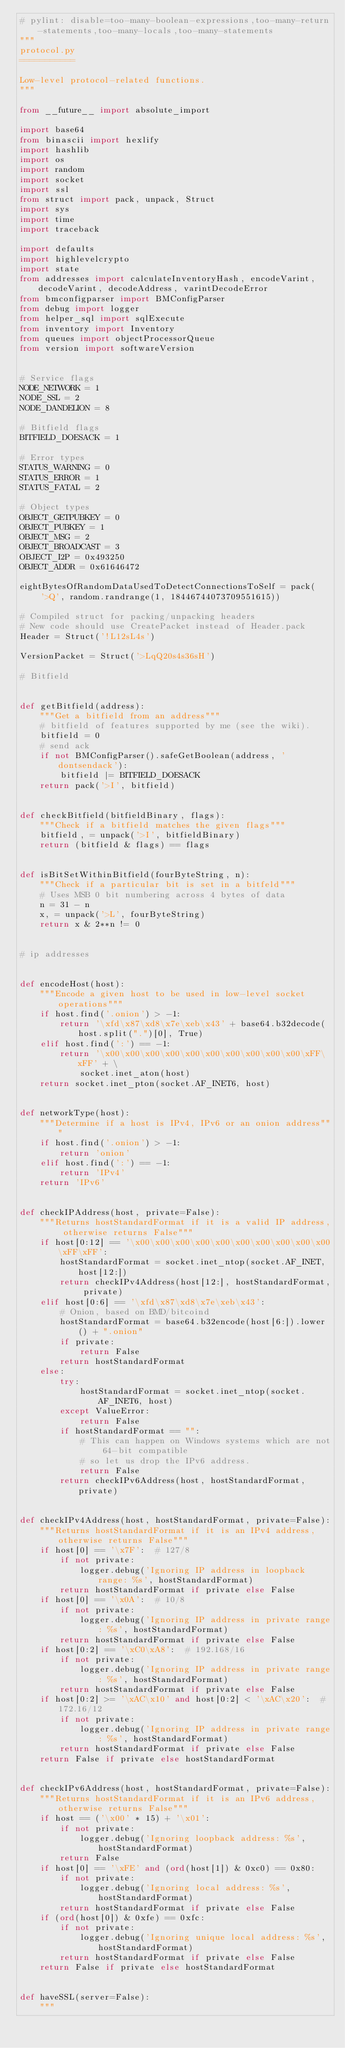Convert code to text. <code><loc_0><loc_0><loc_500><loc_500><_Python_># pylint: disable=too-many-boolean-expressions,too-many-return-statements,too-many-locals,too-many-statements
"""
protocol.py
===========

Low-level protocol-related functions.
"""

from __future__ import absolute_import

import base64
from binascii import hexlify
import hashlib
import os
import random
import socket
import ssl
from struct import pack, unpack, Struct
import sys
import time
import traceback

import defaults
import highlevelcrypto
import state
from addresses import calculateInventoryHash, encodeVarint, decodeVarint, decodeAddress, varintDecodeError
from bmconfigparser import BMConfigParser
from debug import logger
from helper_sql import sqlExecute
from inventory import Inventory
from queues import objectProcessorQueue
from version import softwareVersion


# Service flags
NODE_NETWORK = 1
NODE_SSL = 2
NODE_DANDELION = 8

# Bitfield flags
BITFIELD_DOESACK = 1

# Error types
STATUS_WARNING = 0
STATUS_ERROR = 1
STATUS_FATAL = 2

# Object types
OBJECT_GETPUBKEY = 0
OBJECT_PUBKEY = 1
OBJECT_MSG = 2
OBJECT_BROADCAST = 3
OBJECT_I2P = 0x493250
OBJECT_ADDR = 0x61646472

eightBytesOfRandomDataUsedToDetectConnectionsToSelf = pack(
    '>Q', random.randrange(1, 18446744073709551615))

# Compiled struct for packing/unpacking headers
# New code should use CreatePacket instead of Header.pack
Header = Struct('!L12sL4s')

VersionPacket = Struct('>LqQ20s4s36sH')

# Bitfield


def getBitfield(address):
    """Get a bitfield from an address"""
    # bitfield of features supported by me (see the wiki).
    bitfield = 0
    # send ack
    if not BMConfigParser().safeGetBoolean(address, 'dontsendack'):
        bitfield |= BITFIELD_DOESACK
    return pack('>I', bitfield)


def checkBitfield(bitfieldBinary, flags):
    """Check if a bitfield matches the given flags"""
    bitfield, = unpack('>I', bitfieldBinary)
    return (bitfield & flags) == flags


def isBitSetWithinBitfield(fourByteString, n):
    """Check if a particular bit is set in a bitfeld"""
    # Uses MSB 0 bit numbering across 4 bytes of data
    n = 31 - n
    x, = unpack('>L', fourByteString)
    return x & 2**n != 0


# ip addresses


def encodeHost(host):
    """Encode a given host to be used in low-level socket operations"""
    if host.find('.onion') > -1:
        return '\xfd\x87\xd8\x7e\xeb\x43' + base64.b32decode(host.split(".")[0], True)
    elif host.find(':') == -1:
        return '\x00\x00\x00\x00\x00\x00\x00\x00\x00\x00\xFF\xFF' + \
            socket.inet_aton(host)
    return socket.inet_pton(socket.AF_INET6, host)


def networkType(host):
    """Determine if a host is IPv4, IPv6 or an onion address"""
    if host.find('.onion') > -1:
        return 'onion'
    elif host.find(':') == -1:
        return 'IPv4'
    return 'IPv6'


def checkIPAddress(host, private=False):
    """Returns hostStandardFormat if it is a valid IP address, otherwise returns False"""
    if host[0:12] == '\x00\x00\x00\x00\x00\x00\x00\x00\x00\x00\xFF\xFF':
        hostStandardFormat = socket.inet_ntop(socket.AF_INET, host[12:])
        return checkIPv4Address(host[12:], hostStandardFormat, private)
    elif host[0:6] == '\xfd\x87\xd8\x7e\xeb\x43':
        # Onion, based on BMD/bitcoind
        hostStandardFormat = base64.b32encode(host[6:]).lower() + ".onion"
        if private:
            return False
        return hostStandardFormat
    else:
        try:
            hostStandardFormat = socket.inet_ntop(socket.AF_INET6, host)
        except ValueError:
            return False
        if hostStandardFormat == "":
            # This can happen on Windows systems which are not 64-bit compatible
            # so let us drop the IPv6 address.
            return False
        return checkIPv6Address(host, hostStandardFormat, private)


def checkIPv4Address(host, hostStandardFormat, private=False):
    """Returns hostStandardFormat if it is an IPv4 address, otherwise returns False"""
    if host[0] == '\x7F':  # 127/8
        if not private:
            logger.debug('Ignoring IP address in loopback range: %s', hostStandardFormat)
        return hostStandardFormat if private else False
    if host[0] == '\x0A':  # 10/8
        if not private:
            logger.debug('Ignoring IP address in private range: %s', hostStandardFormat)
        return hostStandardFormat if private else False
    if host[0:2] == '\xC0\xA8':  # 192.168/16
        if not private:
            logger.debug('Ignoring IP address in private range: %s', hostStandardFormat)
        return hostStandardFormat if private else False
    if host[0:2] >= '\xAC\x10' and host[0:2] < '\xAC\x20':  # 172.16/12
        if not private:
            logger.debug('Ignoring IP address in private range: %s', hostStandardFormat)
        return hostStandardFormat if private else False
    return False if private else hostStandardFormat


def checkIPv6Address(host, hostStandardFormat, private=False):
    """Returns hostStandardFormat if it is an IPv6 address, otherwise returns False"""
    if host == ('\x00' * 15) + '\x01':
        if not private:
            logger.debug('Ignoring loopback address: %s', hostStandardFormat)
        return False
    if host[0] == '\xFE' and (ord(host[1]) & 0xc0) == 0x80:
        if not private:
            logger.debug('Ignoring local address: %s', hostStandardFormat)
        return hostStandardFormat if private else False
    if (ord(host[0]) & 0xfe) == 0xfc:
        if not private:
            logger.debug('Ignoring unique local address: %s', hostStandardFormat)
        return hostStandardFormat if private else False
    return False if private else hostStandardFormat


def haveSSL(server=False):
    """</code> 